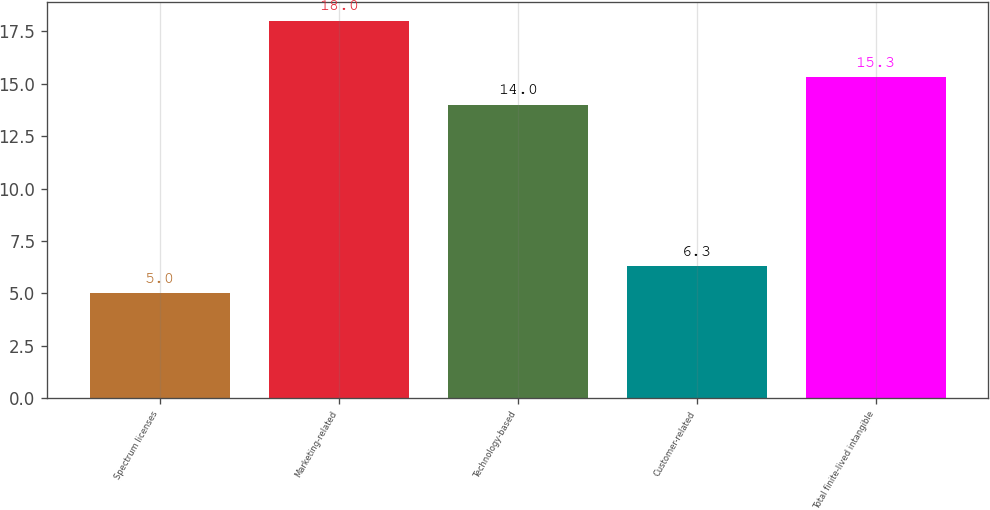Convert chart. <chart><loc_0><loc_0><loc_500><loc_500><bar_chart><fcel>Spectrum licenses<fcel>Marketing-related<fcel>Technology-based<fcel>Customer-related<fcel>Total finite-lived intangible<nl><fcel>5<fcel>18<fcel>14<fcel>6.3<fcel>15.3<nl></chart> 